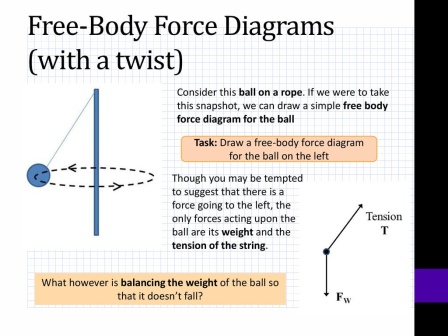Describe the following image. The image displays a presentation slide titled 'Free-Body Force Diagrams (with a twist)' in prominent, bold black text at the top. The background of the slide features a clean white canvas with a subtle grid pattern for reference. On the left side, there's a blue ball connected to a rope depicted with a curved line, indicating it's in motion or swinging. A dashed line extends from the ball’s center, representing the force diagram. On the right, a black and white diagram illustrates two labeled forces acting on the ball: 'T' for tension (directed upwards along the rope) and 'Fw' for weight (directed downwards due to gravity). At the bottom, viewers are encouraged to engage with the content through a task: 'Draw a free-body force diagram for the ball on the left.' This request aims to test and apply their understanding. Overall, this slide serves as a concise and effective teaching tool for explaining and working with free-body force diagrams. 